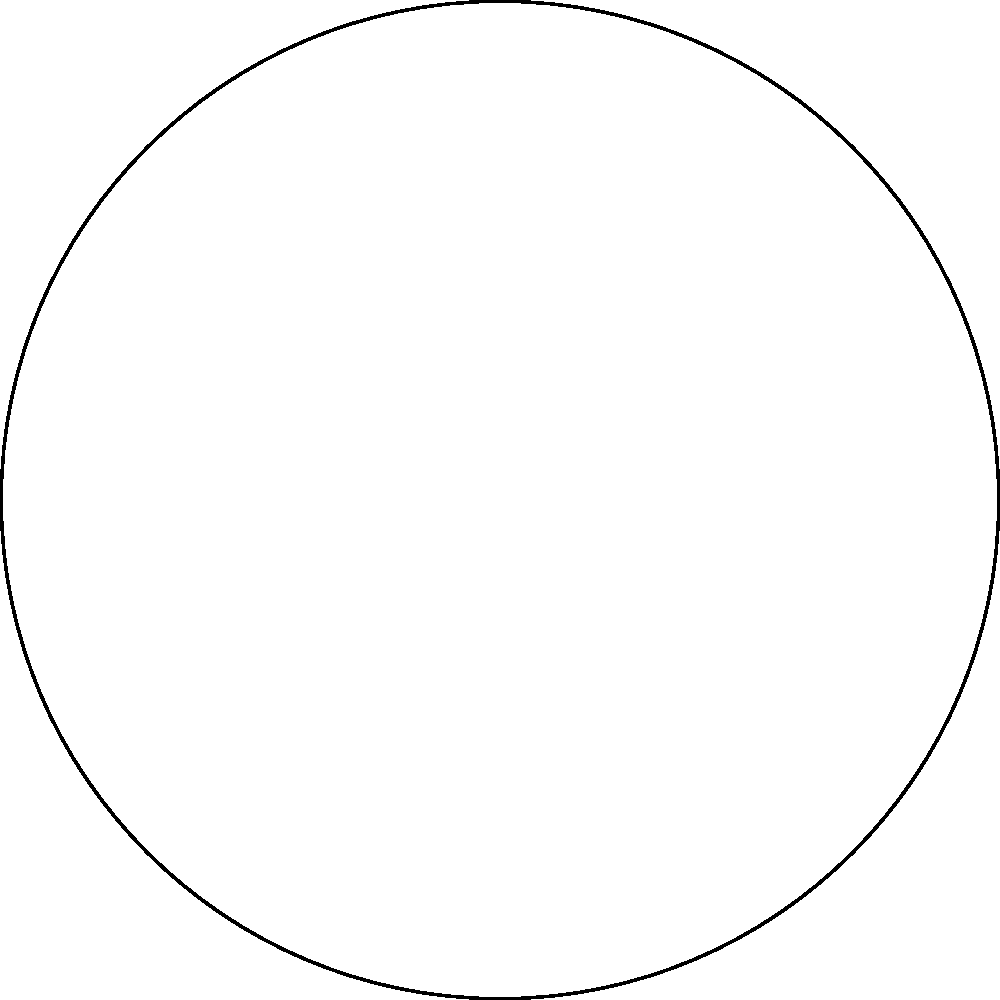In the Poincaré disk model of hyperbolic geometry shown above, triangle ABC is drawn. What is the sum of the interior angles of this hyperbolic triangle? To understand the sum of interior angles in a hyperbolic triangle, let's follow these steps:

1) In Euclidean geometry, the sum of interior angles of a triangle is always 180°. However, in hyperbolic geometry, this is not the case.

2) In the Poincaré disk model:
   - The disk represents the entire hyperbolic plane
   - Straight lines in hyperbolic space are represented by arcs of circles that are perpendicular to the boundary of the disk
   - The boundary of the disk represents points at infinity

3) In hyperbolic geometry, the sum of the interior angles of a triangle is always less than 180°. The difference between 180° and the actual sum is called the defect.

4) The defect is directly proportional to the area of the triangle in hyperbolic space. The larger the triangle (in hyperbolic sense), the greater the defect, and thus the smaller the sum of its angles.

5) In the given diagram, we can see that the triangle ABC occupies a significant portion of the Poincaré disk, indicating that it's relatively large in hyperbolic space.

6) Therefore, we can conclude that the sum of the interior angles of this hyperbolic triangle is strictly less than 180°.

7) The exact sum would depend on the precise positions of points A, B, and C, but we can confidently state that it's less than 180° without calculating the exact value.
Answer: Less than 180° 